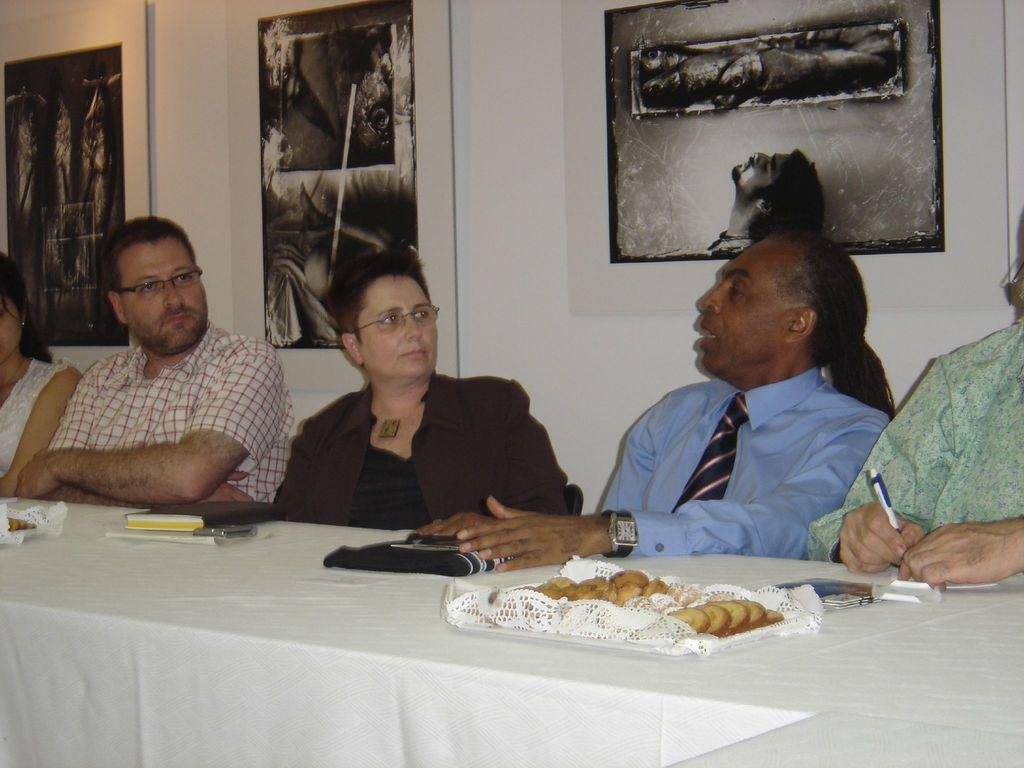What is the person in the image doing? The person is sitting in a chair and speaking. What is the person wearing? The person is wearing a tie and shirt. What can be seen on the table in the image? There is food on a table in the image. What is visible in the background of the image? There is a wall with an image in the background. What type of mitten is the person wearing in the image? The person is not wearing a mitten in the image; they are wearing a tie and shirt. What sound does the alarm make in the image? There is no alarm present in the image. 